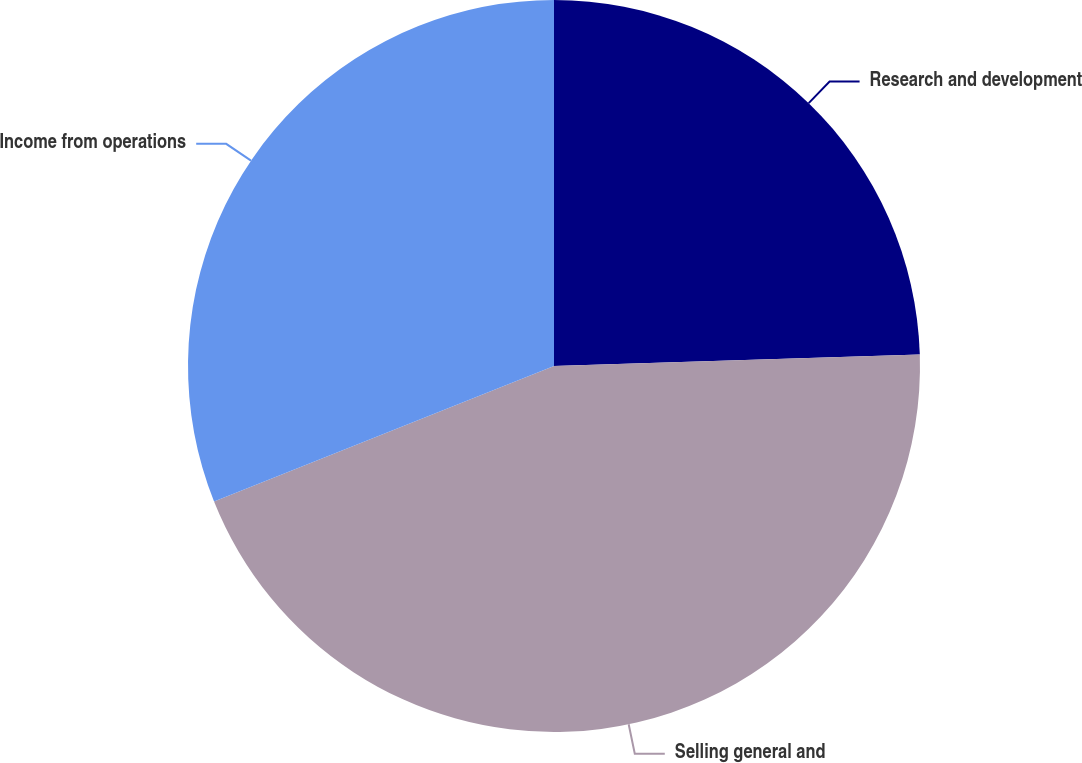Convert chart to OTSL. <chart><loc_0><loc_0><loc_500><loc_500><pie_chart><fcel>Research and development<fcel>Selling general and<fcel>Income from operations<nl><fcel>24.5%<fcel>44.46%<fcel>31.04%<nl></chart> 